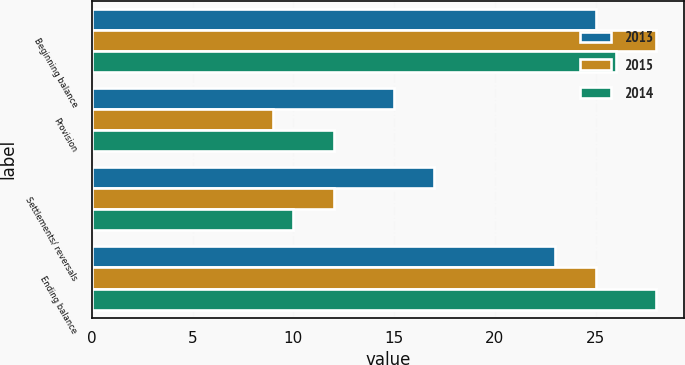<chart> <loc_0><loc_0><loc_500><loc_500><stacked_bar_chart><ecel><fcel>Beginning balance<fcel>Provision<fcel>Settlements/ reversals<fcel>Ending balance<nl><fcel>2013<fcel>25<fcel>15<fcel>17<fcel>23<nl><fcel>2015<fcel>28<fcel>9<fcel>12<fcel>25<nl><fcel>2014<fcel>26<fcel>12<fcel>10<fcel>28<nl></chart> 